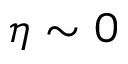<formula> <loc_0><loc_0><loc_500><loc_500>\eta \sim 0</formula> 